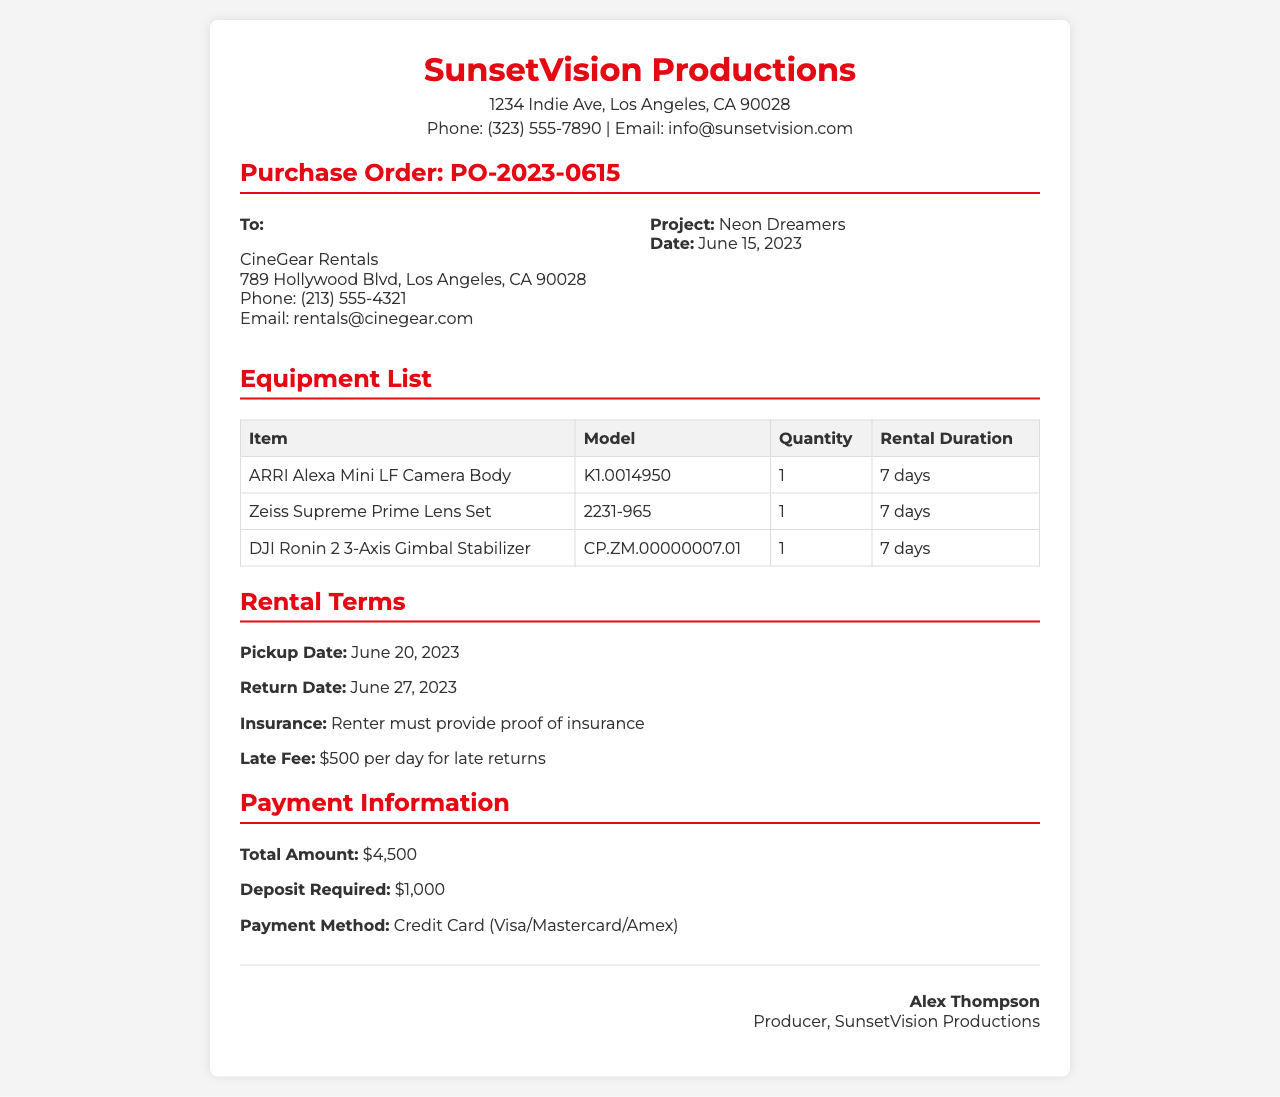what is the project name? The project name is mentioned in the "Project" section of the document as "Neon Dreamers."
Answer: Neon Dreamers what is the purchase order number? The purchase order number is specified in the "Purchase Order" section as "PO-2023-0615."
Answer: PO-2023-0615 what is the rental duration for the equipment? The rental duration for each piece of equipment is stated in the "Equipment List" section as "7 days."
Answer: 7 days who is the rental provider? The rental provider's name is listed under "To" as "CineGear Rentals."
Answer: CineGear Rentals when is the pickup date for the equipment? The pickup date is found in the "Rental Terms" section as "June 20, 2023."
Answer: June 20, 2023 what is the total amount due for the rental? The total amount due is indicated in the "Payment Information" section as "$4,500."
Answer: $4,500 how much is the deposit required? The deposit required is specified in the "Payment Information" section as "$1,000."
Answer: $1,000 what is the late fee mentioned in the document? The late fee is described in the "Rental Terms" section as "$500 per day for late returns."
Answer: $500 per day who signed the document? The document is signed by "Alex Thompson," whose name appears in the signature section.
Answer: Alex Thompson 